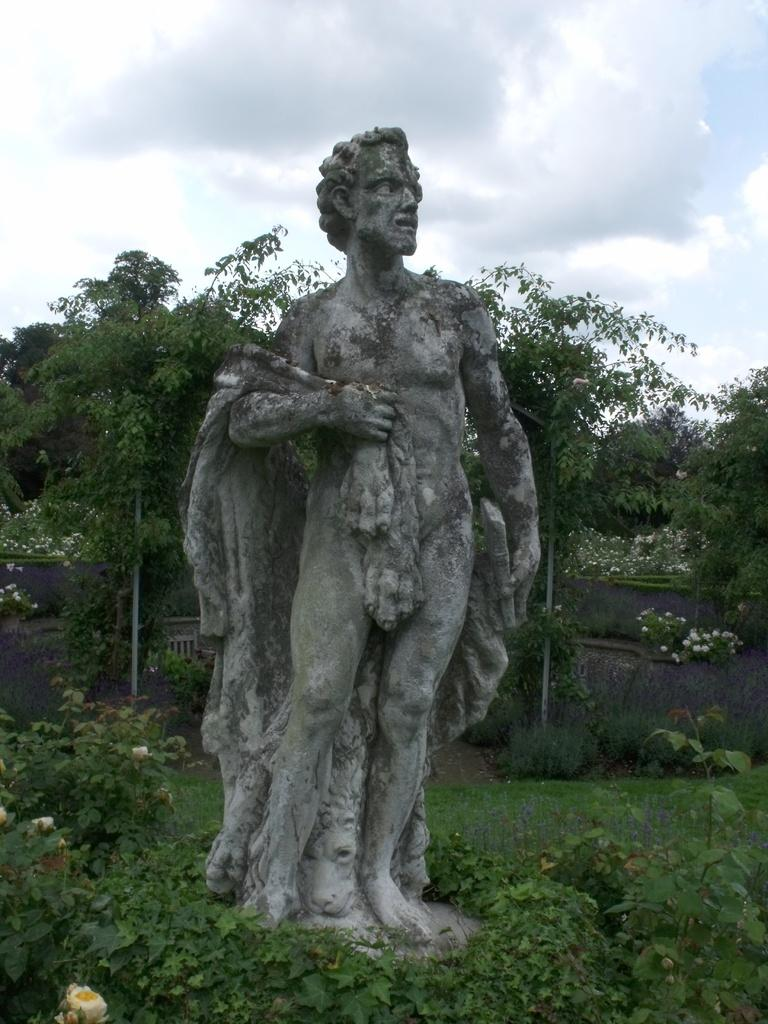What type of living organisms can be seen in the image? Plants can be seen in the image. What is located in the middle of the image? There is a sculpture in the middle of the image. What can be seen in the background of the image? Trees and the sky are visible in the background of the image. What type of connection is being made between the plants and the sculpture in the image? There is no indication of a connection between the plants and the sculpture in the image. Can you see any socks on the plants or sculpture in the image? There are no socks present in the image. 